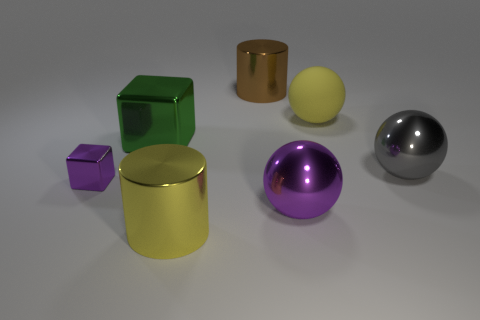Subtract all big yellow balls. How many balls are left? 2 Add 2 large cylinders. How many objects exist? 9 Subtract all yellow balls. How many balls are left? 2 Subtract all cubes. How many objects are left? 5 Subtract 0 blue spheres. How many objects are left? 7 Subtract 2 cubes. How many cubes are left? 0 Subtract all blue spheres. Subtract all blue blocks. How many spheres are left? 3 Subtract all large shiny cylinders. Subtract all brown cylinders. How many objects are left? 4 Add 7 big gray balls. How many big gray balls are left? 8 Add 6 tiny gray rubber cylinders. How many tiny gray rubber cylinders exist? 6 